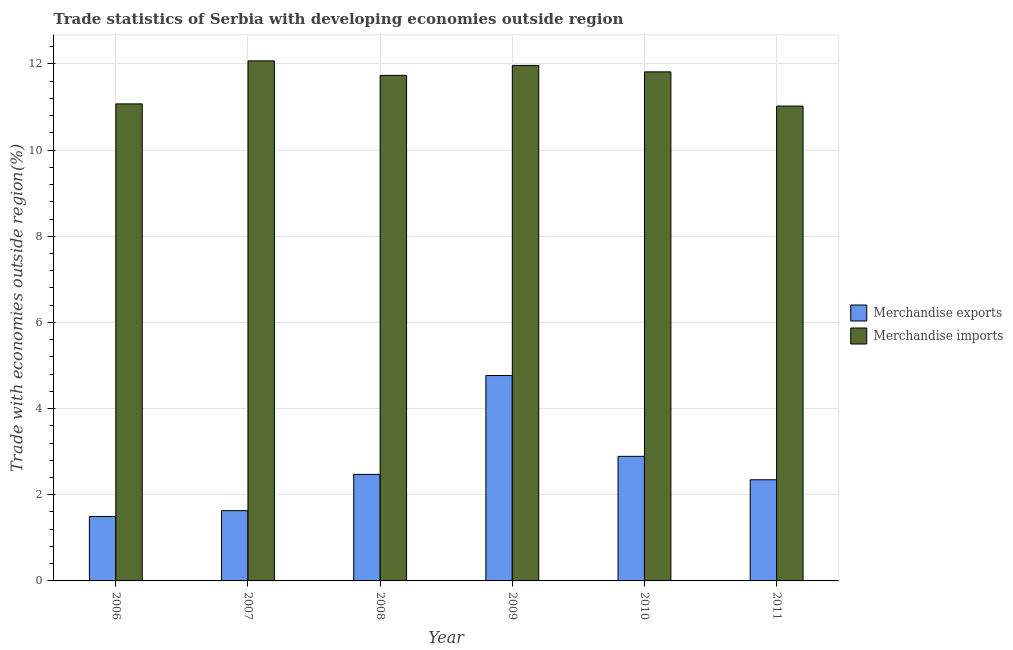How many different coloured bars are there?
Your answer should be compact. 2. How many groups of bars are there?
Your answer should be very brief. 6. Are the number of bars on each tick of the X-axis equal?
Offer a very short reply. Yes. How many bars are there on the 5th tick from the left?
Make the answer very short. 2. What is the label of the 1st group of bars from the left?
Your answer should be very brief. 2006. What is the merchandise exports in 2011?
Your response must be concise. 2.35. Across all years, what is the maximum merchandise exports?
Offer a very short reply. 4.77. Across all years, what is the minimum merchandise imports?
Your answer should be very brief. 11.02. In which year was the merchandise exports maximum?
Make the answer very short. 2009. In which year was the merchandise imports minimum?
Your answer should be compact. 2011. What is the total merchandise imports in the graph?
Give a very brief answer. 69.68. What is the difference between the merchandise exports in 2007 and that in 2009?
Your answer should be very brief. -3.14. What is the difference between the merchandise imports in 2008 and the merchandise exports in 2010?
Offer a terse response. -0.08. What is the average merchandise exports per year?
Your answer should be very brief. 2.6. In the year 2011, what is the difference between the merchandise exports and merchandise imports?
Your response must be concise. 0. In how many years, is the merchandise imports greater than 10 %?
Offer a very short reply. 6. What is the ratio of the merchandise exports in 2007 to that in 2010?
Provide a short and direct response. 0.56. Is the merchandise imports in 2007 less than that in 2009?
Offer a terse response. No. Is the difference between the merchandise exports in 2008 and 2010 greater than the difference between the merchandise imports in 2008 and 2010?
Make the answer very short. No. What is the difference between the highest and the second highest merchandise imports?
Keep it short and to the point. 0.11. What is the difference between the highest and the lowest merchandise imports?
Provide a short and direct response. 1.05. In how many years, is the merchandise exports greater than the average merchandise exports taken over all years?
Offer a very short reply. 2. What does the 1st bar from the left in 2009 represents?
Give a very brief answer. Merchandise exports. How many bars are there?
Provide a succinct answer. 12. Are all the bars in the graph horizontal?
Your answer should be compact. No. What is the difference between two consecutive major ticks on the Y-axis?
Your answer should be compact. 2. Are the values on the major ticks of Y-axis written in scientific E-notation?
Provide a succinct answer. No. Does the graph contain grids?
Provide a succinct answer. Yes. How many legend labels are there?
Your answer should be very brief. 2. How are the legend labels stacked?
Keep it short and to the point. Vertical. What is the title of the graph?
Offer a very short reply. Trade statistics of Serbia with developing economies outside region. What is the label or title of the Y-axis?
Your answer should be compact. Trade with economies outside region(%). What is the Trade with economies outside region(%) of Merchandise exports in 2006?
Offer a very short reply. 1.5. What is the Trade with economies outside region(%) in Merchandise imports in 2006?
Provide a short and direct response. 11.07. What is the Trade with economies outside region(%) of Merchandise exports in 2007?
Keep it short and to the point. 1.63. What is the Trade with economies outside region(%) of Merchandise imports in 2007?
Your answer should be very brief. 12.07. What is the Trade with economies outside region(%) in Merchandise exports in 2008?
Offer a terse response. 2.47. What is the Trade with economies outside region(%) of Merchandise imports in 2008?
Provide a succinct answer. 11.73. What is the Trade with economies outside region(%) in Merchandise exports in 2009?
Offer a very short reply. 4.77. What is the Trade with economies outside region(%) in Merchandise imports in 2009?
Keep it short and to the point. 11.97. What is the Trade with economies outside region(%) in Merchandise exports in 2010?
Your answer should be very brief. 2.89. What is the Trade with economies outside region(%) in Merchandise imports in 2010?
Ensure brevity in your answer.  11.82. What is the Trade with economies outside region(%) of Merchandise exports in 2011?
Make the answer very short. 2.35. What is the Trade with economies outside region(%) of Merchandise imports in 2011?
Make the answer very short. 11.02. Across all years, what is the maximum Trade with economies outside region(%) in Merchandise exports?
Your answer should be very brief. 4.77. Across all years, what is the maximum Trade with economies outside region(%) in Merchandise imports?
Your answer should be compact. 12.07. Across all years, what is the minimum Trade with economies outside region(%) in Merchandise exports?
Give a very brief answer. 1.5. Across all years, what is the minimum Trade with economies outside region(%) in Merchandise imports?
Give a very brief answer. 11.02. What is the total Trade with economies outside region(%) in Merchandise exports in the graph?
Ensure brevity in your answer.  15.61. What is the total Trade with economies outside region(%) of Merchandise imports in the graph?
Offer a very short reply. 69.68. What is the difference between the Trade with economies outside region(%) of Merchandise exports in 2006 and that in 2007?
Make the answer very short. -0.14. What is the difference between the Trade with economies outside region(%) of Merchandise imports in 2006 and that in 2007?
Keep it short and to the point. -1. What is the difference between the Trade with economies outside region(%) of Merchandise exports in 2006 and that in 2008?
Ensure brevity in your answer.  -0.98. What is the difference between the Trade with economies outside region(%) in Merchandise imports in 2006 and that in 2008?
Your response must be concise. -0.66. What is the difference between the Trade with economies outside region(%) of Merchandise exports in 2006 and that in 2009?
Offer a very short reply. -3.27. What is the difference between the Trade with economies outside region(%) in Merchandise imports in 2006 and that in 2009?
Make the answer very short. -0.89. What is the difference between the Trade with economies outside region(%) of Merchandise exports in 2006 and that in 2010?
Your response must be concise. -1.4. What is the difference between the Trade with economies outside region(%) of Merchandise imports in 2006 and that in 2010?
Your answer should be very brief. -0.74. What is the difference between the Trade with economies outside region(%) in Merchandise exports in 2006 and that in 2011?
Offer a terse response. -0.85. What is the difference between the Trade with economies outside region(%) of Merchandise imports in 2006 and that in 2011?
Keep it short and to the point. 0.05. What is the difference between the Trade with economies outside region(%) of Merchandise exports in 2007 and that in 2008?
Ensure brevity in your answer.  -0.84. What is the difference between the Trade with economies outside region(%) in Merchandise imports in 2007 and that in 2008?
Provide a succinct answer. 0.34. What is the difference between the Trade with economies outside region(%) in Merchandise exports in 2007 and that in 2009?
Your answer should be compact. -3.14. What is the difference between the Trade with economies outside region(%) in Merchandise imports in 2007 and that in 2009?
Provide a succinct answer. 0.11. What is the difference between the Trade with economies outside region(%) of Merchandise exports in 2007 and that in 2010?
Make the answer very short. -1.26. What is the difference between the Trade with economies outside region(%) of Merchandise imports in 2007 and that in 2010?
Your answer should be compact. 0.26. What is the difference between the Trade with economies outside region(%) of Merchandise exports in 2007 and that in 2011?
Your answer should be very brief. -0.72. What is the difference between the Trade with economies outside region(%) of Merchandise imports in 2007 and that in 2011?
Your answer should be compact. 1.05. What is the difference between the Trade with economies outside region(%) of Merchandise exports in 2008 and that in 2009?
Offer a very short reply. -2.29. What is the difference between the Trade with economies outside region(%) in Merchandise imports in 2008 and that in 2009?
Your response must be concise. -0.23. What is the difference between the Trade with economies outside region(%) in Merchandise exports in 2008 and that in 2010?
Provide a short and direct response. -0.42. What is the difference between the Trade with economies outside region(%) of Merchandise imports in 2008 and that in 2010?
Provide a succinct answer. -0.08. What is the difference between the Trade with economies outside region(%) of Merchandise exports in 2008 and that in 2011?
Offer a terse response. 0.13. What is the difference between the Trade with economies outside region(%) of Merchandise imports in 2008 and that in 2011?
Provide a short and direct response. 0.71. What is the difference between the Trade with economies outside region(%) of Merchandise exports in 2009 and that in 2010?
Make the answer very short. 1.88. What is the difference between the Trade with economies outside region(%) of Merchandise imports in 2009 and that in 2010?
Offer a terse response. 0.15. What is the difference between the Trade with economies outside region(%) of Merchandise exports in 2009 and that in 2011?
Offer a very short reply. 2.42. What is the difference between the Trade with economies outside region(%) of Merchandise imports in 2009 and that in 2011?
Offer a very short reply. 0.94. What is the difference between the Trade with economies outside region(%) in Merchandise exports in 2010 and that in 2011?
Provide a succinct answer. 0.54. What is the difference between the Trade with economies outside region(%) in Merchandise imports in 2010 and that in 2011?
Give a very brief answer. 0.79. What is the difference between the Trade with economies outside region(%) in Merchandise exports in 2006 and the Trade with economies outside region(%) in Merchandise imports in 2007?
Offer a very short reply. -10.58. What is the difference between the Trade with economies outside region(%) of Merchandise exports in 2006 and the Trade with economies outside region(%) of Merchandise imports in 2008?
Provide a short and direct response. -10.24. What is the difference between the Trade with economies outside region(%) of Merchandise exports in 2006 and the Trade with economies outside region(%) of Merchandise imports in 2009?
Offer a very short reply. -10.47. What is the difference between the Trade with economies outside region(%) of Merchandise exports in 2006 and the Trade with economies outside region(%) of Merchandise imports in 2010?
Offer a very short reply. -10.32. What is the difference between the Trade with economies outside region(%) of Merchandise exports in 2006 and the Trade with economies outside region(%) of Merchandise imports in 2011?
Offer a terse response. -9.53. What is the difference between the Trade with economies outside region(%) of Merchandise exports in 2007 and the Trade with economies outside region(%) of Merchandise imports in 2008?
Make the answer very short. -10.1. What is the difference between the Trade with economies outside region(%) of Merchandise exports in 2007 and the Trade with economies outside region(%) of Merchandise imports in 2009?
Your answer should be very brief. -10.33. What is the difference between the Trade with economies outside region(%) in Merchandise exports in 2007 and the Trade with economies outside region(%) in Merchandise imports in 2010?
Make the answer very short. -10.18. What is the difference between the Trade with economies outside region(%) in Merchandise exports in 2007 and the Trade with economies outside region(%) in Merchandise imports in 2011?
Offer a terse response. -9.39. What is the difference between the Trade with economies outside region(%) in Merchandise exports in 2008 and the Trade with economies outside region(%) in Merchandise imports in 2009?
Provide a succinct answer. -9.49. What is the difference between the Trade with economies outside region(%) in Merchandise exports in 2008 and the Trade with economies outside region(%) in Merchandise imports in 2010?
Keep it short and to the point. -9.34. What is the difference between the Trade with economies outside region(%) in Merchandise exports in 2008 and the Trade with economies outside region(%) in Merchandise imports in 2011?
Ensure brevity in your answer.  -8.55. What is the difference between the Trade with economies outside region(%) of Merchandise exports in 2009 and the Trade with economies outside region(%) of Merchandise imports in 2010?
Offer a very short reply. -7.05. What is the difference between the Trade with economies outside region(%) in Merchandise exports in 2009 and the Trade with economies outside region(%) in Merchandise imports in 2011?
Your answer should be very brief. -6.25. What is the difference between the Trade with economies outside region(%) of Merchandise exports in 2010 and the Trade with economies outside region(%) of Merchandise imports in 2011?
Your answer should be very brief. -8.13. What is the average Trade with economies outside region(%) in Merchandise exports per year?
Provide a short and direct response. 2.6. What is the average Trade with economies outside region(%) in Merchandise imports per year?
Provide a succinct answer. 11.61. In the year 2006, what is the difference between the Trade with economies outside region(%) in Merchandise exports and Trade with economies outside region(%) in Merchandise imports?
Provide a short and direct response. -9.58. In the year 2007, what is the difference between the Trade with economies outside region(%) of Merchandise exports and Trade with economies outside region(%) of Merchandise imports?
Your response must be concise. -10.44. In the year 2008, what is the difference between the Trade with economies outside region(%) of Merchandise exports and Trade with economies outside region(%) of Merchandise imports?
Keep it short and to the point. -9.26. In the year 2009, what is the difference between the Trade with economies outside region(%) of Merchandise exports and Trade with economies outside region(%) of Merchandise imports?
Your answer should be very brief. -7.2. In the year 2010, what is the difference between the Trade with economies outside region(%) of Merchandise exports and Trade with economies outside region(%) of Merchandise imports?
Offer a very short reply. -8.92. In the year 2011, what is the difference between the Trade with economies outside region(%) of Merchandise exports and Trade with economies outside region(%) of Merchandise imports?
Offer a terse response. -8.67. What is the ratio of the Trade with economies outside region(%) in Merchandise exports in 2006 to that in 2007?
Keep it short and to the point. 0.92. What is the ratio of the Trade with economies outside region(%) of Merchandise imports in 2006 to that in 2007?
Make the answer very short. 0.92. What is the ratio of the Trade with economies outside region(%) in Merchandise exports in 2006 to that in 2008?
Offer a very short reply. 0.6. What is the ratio of the Trade with economies outside region(%) in Merchandise imports in 2006 to that in 2008?
Ensure brevity in your answer.  0.94. What is the ratio of the Trade with economies outside region(%) in Merchandise exports in 2006 to that in 2009?
Provide a succinct answer. 0.31. What is the ratio of the Trade with economies outside region(%) of Merchandise imports in 2006 to that in 2009?
Offer a terse response. 0.93. What is the ratio of the Trade with economies outside region(%) in Merchandise exports in 2006 to that in 2010?
Your answer should be very brief. 0.52. What is the ratio of the Trade with economies outside region(%) of Merchandise imports in 2006 to that in 2010?
Offer a very short reply. 0.94. What is the ratio of the Trade with economies outside region(%) in Merchandise exports in 2006 to that in 2011?
Your answer should be compact. 0.64. What is the ratio of the Trade with economies outside region(%) in Merchandise exports in 2007 to that in 2008?
Provide a short and direct response. 0.66. What is the ratio of the Trade with economies outside region(%) of Merchandise imports in 2007 to that in 2008?
Ensure brevity in your answer.  1.03. What is the ratio of the Trade with economies outside region(%) of Merchandise exports in 2007 to that in 2009?
Keep it short and to the point. 0.34. What is the ratio of the Trade with economies outside region(%) of Merchandise imports in 2007 to that in 2009?
Offer a very short reply. 1.01. What is the ratio of the Trade with economies outside region(%) in Merchandise exports in 2007 to that in 2010?
Your answer should be compact. 0.56. What is the ratio of the Trade with economies outside region(%) of Merchandise imports in 2007 to that in 2010?
Your answer should be very brief. 1.02. What is the ratio of the Trade with economies outside region(%) in Merchandise exports in 2007 to that in 2011?
Provide a succinct answer. 0.69. What is the ratio of the Trade with economies outside region(%) in Merchandise imports in 2007 to that in 2011?
Your answer should be very brief. 1.1. What is the ratio of the Trade with economies outside region(%) of Merchandise exports in 2008 to that in 2009?
Keep it short and to the point. 0.52. What is the ratio of the Trade with economies outside region(%) of Merchandise imports in 2008 to that in 2009?
Make the answer very short. 0.98. What is the ratio of the Trade with economies outside region(%) of Merchandise exports in 2008 to that in 2010?
Provide a short and direct response. 0.86. What is the ratio of the Trade with economies outside region(%) in Merchandise exports in 2008 to that in 2011?
Keep it short and to the point. 1.05. What is the ratio of the Trade with economies outside region(%) of Merchandise imports in 2008 to that in 2011?
Your answer should be compact. 1.06. What is the ratio of the Trade with economies outside region(%) in Merchandise exports in 2009 to that in 2010?
Offer a terse response. 1.65. What is the ratio of the Trade with economies outside region(%) of Merchandise imports in 2009 to that in 2010?
Make the answer very short. 1.01. What is the ratio of the Trade with economies outside region(%) of Merchandise exports in 2009 to that in 2011?
Provide a succinct answer. 2.03. What is the ratio of the Trade with economies outside region(%) in Merchandise imports in 2009 to that in 2011?
Ensure brevity in your answer.  1.09. What is the ratio of the Trade with economies outside region(%) in Merchandise exports in 2010 to that in 2011?
Provide a succinct answer. 1.23. What is the ratio of the Trade with economies outside region(%) of Merchandise imports in 2010 to that in 2011?
Provide a succinct answer. 1.07. What is the difference between the highest and the second highest Trade with economies outside region(%) in Merchandise exports?
Your answer should be compact. 1.88. What is the difference between the highest and the second highest Trade with economies outside region(%) of Merchandise imports?
Your answer should be compact. 0.11. What is the difference between the highest and the lowest Trade with economies outside region(%) of Merchandise exports?
Your answer should be compact. 3.27. What is the difference between the highest and the lowest Trade with economies outside region(%) in Merchandise imports?
Your response must be concise. 1.05. 